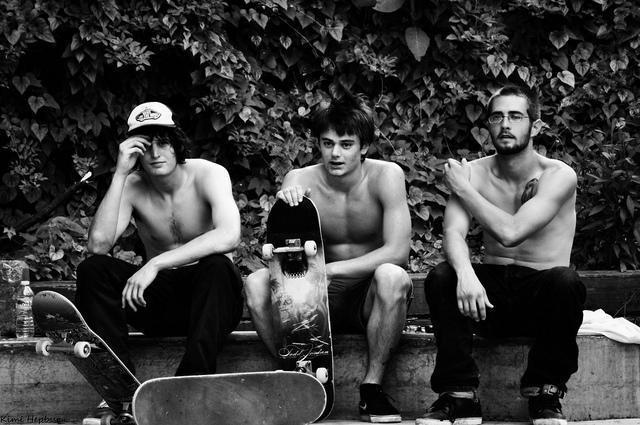How many people in this photo are wearing glasses?
Give a very brief answer. 1. How many skateboards can you see?
Give a very brief answer. 3. How many people are in the photo?
Give a very brief answer. 3. 